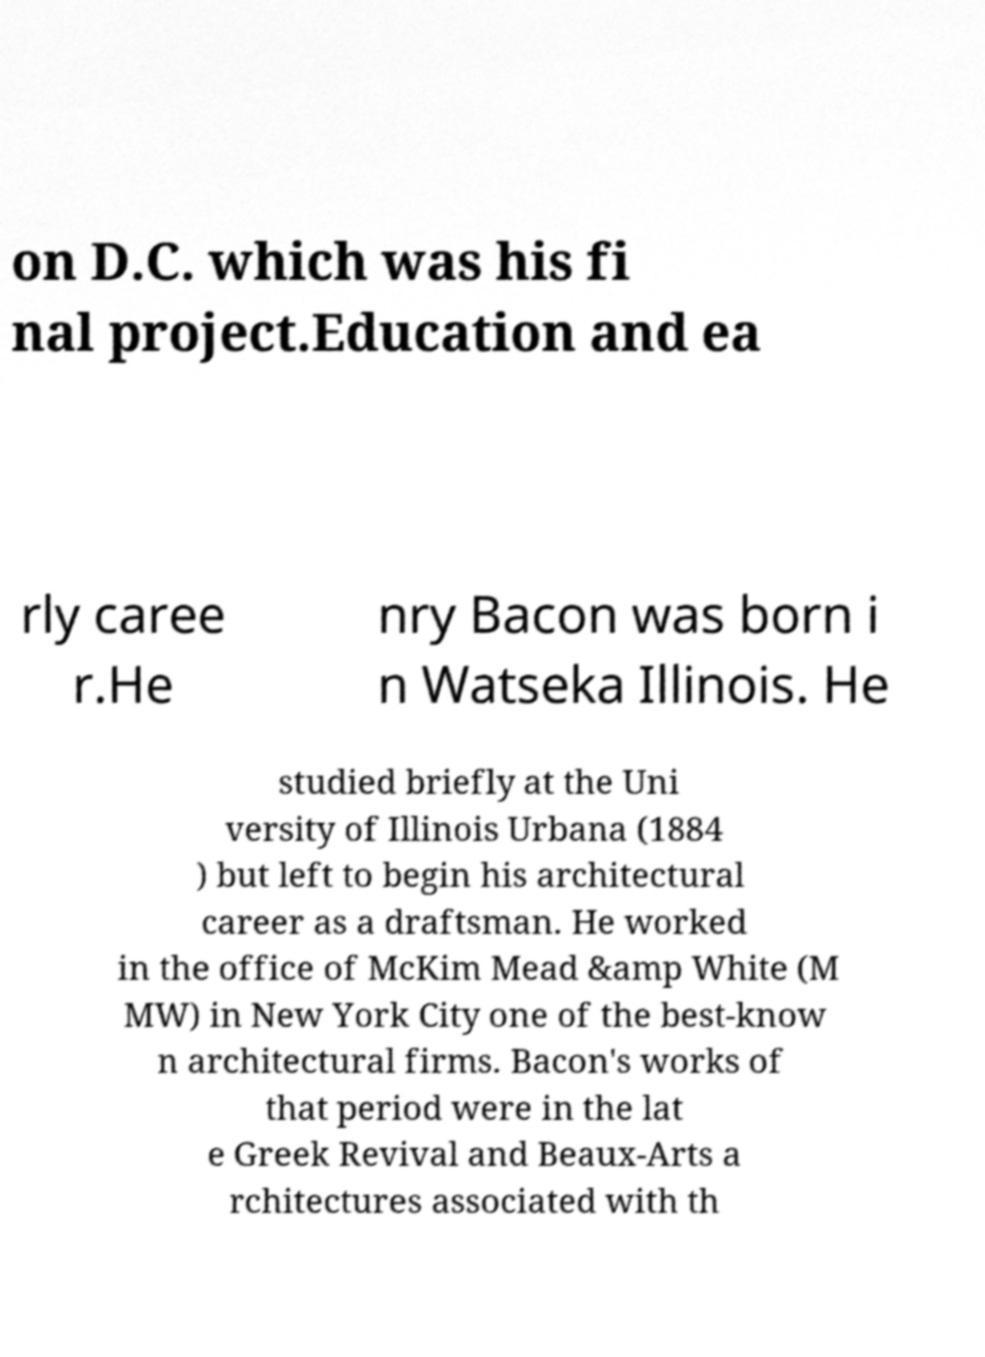For documentation purposes, I need the text within this image transcribed. Could you provide that? on D.C. which was his fi nal project.Education and ea rly caree r.He nry Bacon was born i n Watseka Illinois. He studied briefly at the Uni versity of Illinois Urbana (1884 ) but left to begin his architectural career as a draftsman. He worked in the office of McKim Mead &amp White (M MW) in New York City one of the best-know n architectural firms. Bacon's works of that period were in the lat e Greek Revival and Beaux-Arts a rchitectures associated with th 